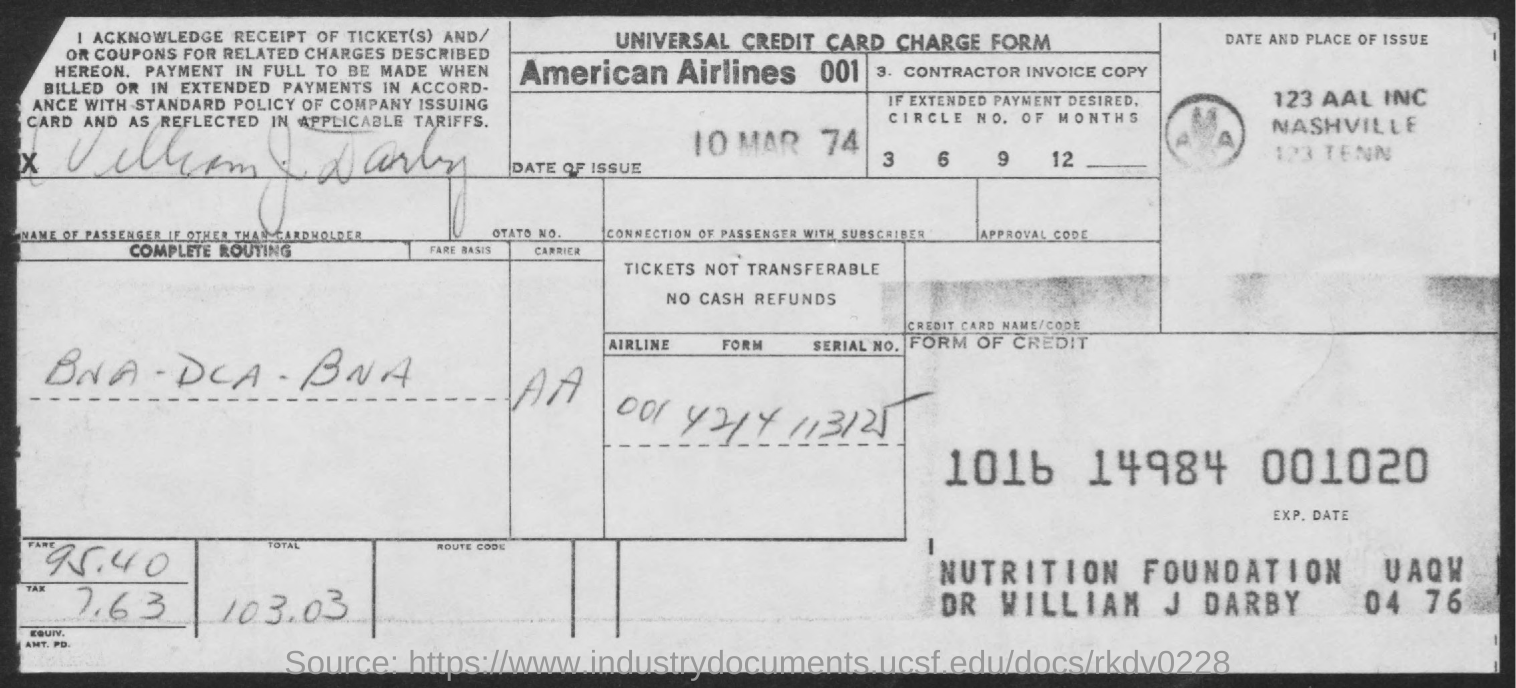What is this form known as?
Provide a short and direct response. Universal Credit Card Charge Form. What is the name of airlines?
Give a very brief answer. American Airlines 001. What is the date of issue?
Provide a succinct answer. 10 Mar 74. What is the fare?
Provide a short and direct response. 95.40. What is the tax levied?
Your answer should be very brief. 7.63. What is the total fare?
Ensure brevity in your answer.  103.03. 